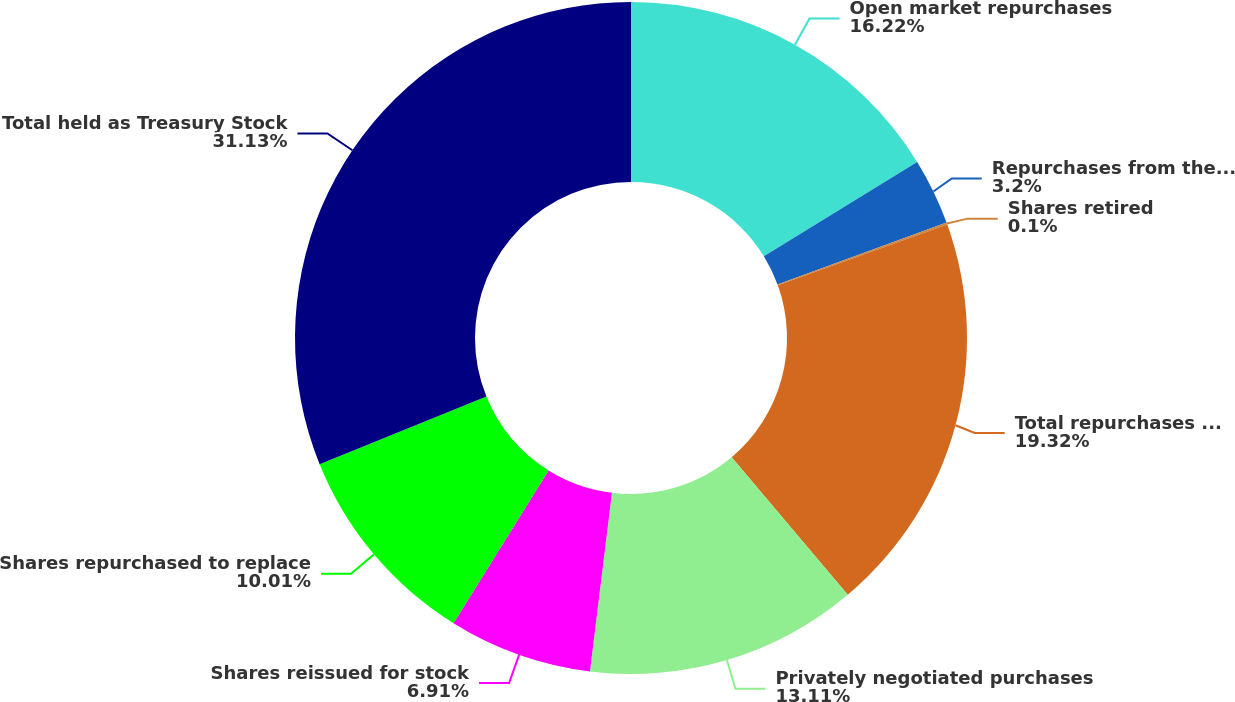<chart> <loc_0><loc_0><loc_500><loc_500><pie_chart><fcel>Open market repurchases<fcel>Repurchases from the Milton<fcel>Shares retired<fcel>Total repurchases under<fcel>Privately negotiated purchases<fcel>Shares reissued for stock<fcel>Shares repurchased to replace<fcel>Total held as Treasury Stock<nl><fcel>16.22%<fcel>3.2%<fcel>0.1%<fcel>19.32%<fcel>13.11%<fcel>6.91%<fcel>10.01%<fcel>31.13%<nl></chart> 